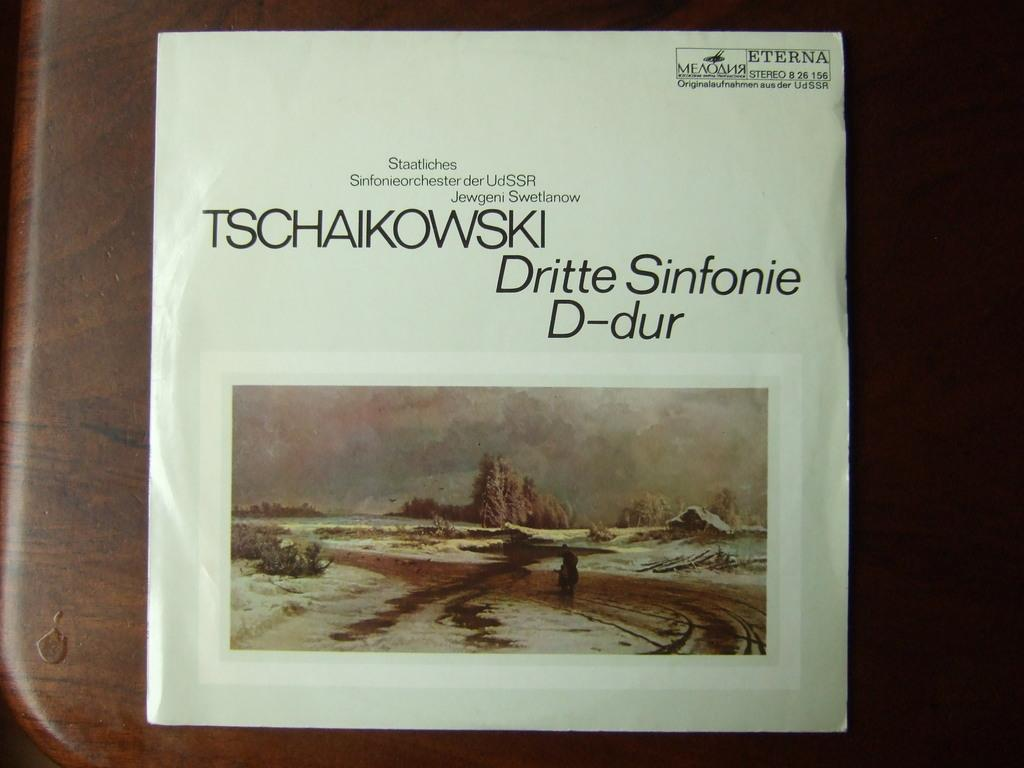<image>
Create a compact narrative representing the image presented. A book titled TSCHAIKOWSKI has a picture of a snowy scene 